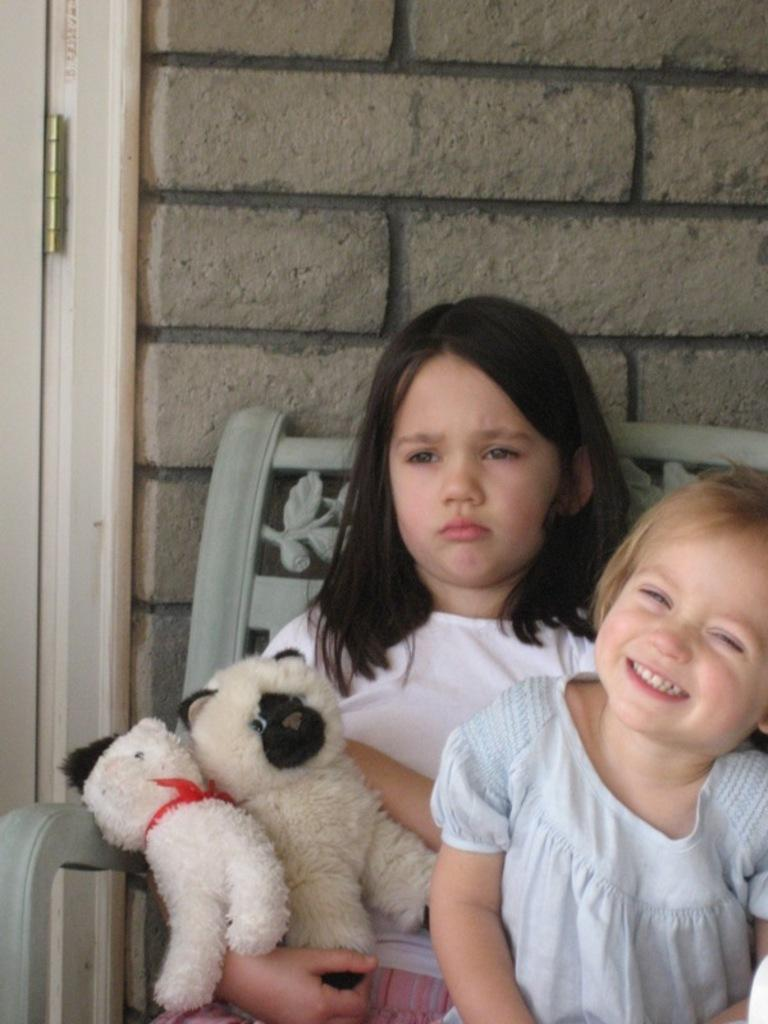How many people are in the image? There are two girls in the image. What are the girls doing in the image? The girls are seated on chairs. What are the girls holding in their hands? The girls are holding soft toys in their hands. What type of brass instrument can be seen in the image? There is no brass instrument present in the image. 